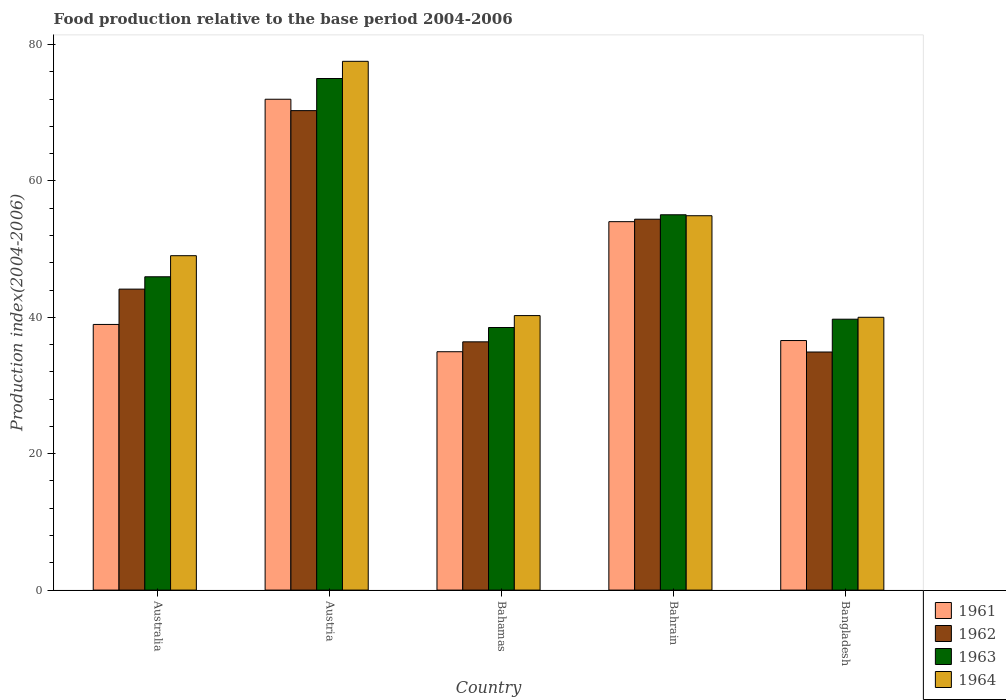How many groups of bars are there?
Provide a succinct answer. 5. Are the number of bars per tick equal to the number of legend labels?
Give a very brief answer. Yes. How many bars are there on the 3rd tick from the left?
Your answer should be very brief. 4. How many bars are there on the 4th tick from the right?
Ensure brevity in your answer.  4. In how many cases, is the number of bars for a given country not equal to the number of legend labels?
Your answer should be very brief. 0. What is the food production index in 1962 in Austria?
Provide a short and direct response. 70.3. Across all countries, what is the maximum food production index in 1961?
Your answer should be compact. 71.97. In which country was the food production index in 1962 maximum?
Make the answer very short. Austria. In which country was the food production index in 1961 minimum?
Your answer should be compact. Bahamas. What is the total food production index in 1964 in the graph?
Ensure brevity in your answer.  261.7. What is the difference between the food production index in 1962 in Bahrain and that in Bangladesh?
Give a very brief answer. 19.47. What is the difference between the food production index in 1964 in Bahrain and the food production index in 1963 in Bangladesh?
Your answer should be very brief. 15.17. What is the average food production index in 1964 per country?
Keep it short and to the point. 52.34. What is the difference between the food production index of/in 1964 and food production index of/in 1963 in Australia?
Make the answer very short. 3.09. What is the ratio of the food production index in 1964 in Australia to that in Austria?
Provide a short and direct response. 0.63. Is the food production index in 1961 in Bahrain less than that in Bangladesh?
Provide a short and direct response. No. Is the difference between the food production index in 1964 in Australia and Bangladesh greater than the difference between the food production index in 1963 in Australia and Bangladesh?
Provide a succinct answer. Yes. What is the difference between the highest and the second highest food production index in 1963?
Keep it short and to the point. 29.07. What is the difference between the highest and the lowest food production index in 1961?
Make the answer very short. 37.02. In how many countries, is the food production index in 1961 greater than the average food production index in 1961 taken over all countries?
Your answer should be compact. 2. Is the sum of the food production index in 1963 in Austria and Bangladesh greater than the maximum food production index in 1964 across all countries?
Offer a terse response. Yes. What does the 3rd bar from the left in Bahamas represents?
Ensure brevity in your answer.  1963. What does the 2nd bar from the right in Bahrain represents?
Provide a succinct answer. 1963. Does the graph contain grids?
Your response must be concise. No. How many legend labels are there?
Keep it short and to the point. 4. How are the legend labels stacked?
Provide a short and direct response. Vertical. What is the title of the graph?
Give a very brief answer. Food production relative to the base period 2004-2006. Does "2004" appear as one of the legend labels in the graph?
Your response must be concise. No. What is the label or title of the Y-axis?
Your response must be concise. Production index(2004-2006). What is the Production index(2004-2006) of 1961 in Australia?
Offer a very short reply. 38.95. What is the Production index(2004-2006) in 1962 in Australia?
Keep it short and to the point. 44.13. What is the Production index(2004-2006) of 1963 in Australia?
Provide a short and direct response. 45.94. What is the Production index(2004-2006) in 1964 in Australia?
Provide a succinct answer. 49.03. What is the Production index(2004-2006) in 1961 in Austria?
Your answer should be compact. 71.97. What is the Production index(2004-2006) in 1962 in Austria?
Your response must be concise. 70.3. What is the Production index(2004-2006) in 1963 in Austria?
Your answer should be very brief. 75.01. What is the Production index(2004-2006) of 1964 in Austria?
Give a very brief answer. 77.53. What is the Production index(2004-2006) in 1961 in Bahamas?
Your response must be concise. 34.95. What is the Production index(2004-2006) in 1962 in Bahamas?
Make the answer very short. 36.4. What is the Production index(2004-2006) in 1963 in Bahamas?
Ensure brevity in your answer.  38.5. What is the Production index(2004-2006) of 1964 in Bahamas?
Keep it short and to the point. 40.25. What is the Production index(2004-2006) of 1961 in Bahrain?
Provide a short and direct response. 54.02. What is the Production index(2004-2006) of 1962 in Bahrain?
Offer a terse response. 54.38. What is the Production index(2004-2006) in 1963 in Bahrain?
Your answer should be compact. 55.03. What is the Production index(2004-2006) in 1964 in Bahrain?
Make the answer very short. 54.89. What is the Production index(2004-2006) in 1961 in Bangladesh?
Provide a succinct answer. 36.59. What is the Production index(2004-2006) in 1962 in Bangladesh?
Make the answer very short. 34.91. What is the Production index(2004-2006) of 1963 in Bangladesh?
Ensure brevity in your answer.  39.72. Across all countries, what is the maximum Production index(2004-2006) of 1961?
Provide a short and direct response. 71.97. Across all countries, what is the maximum Production index(2004-2006) of 1962?
Make the answer very short. 70.3. Across all countries, what is the maximum Production index(2004-2006) in 1963?
Provide a succinct answer. 75.01. Across all countries, what is the maximum Production index(2004-2006) in 1964?
Keep it short and to the point. 77.53. Across all countries, what is the minimum Production index(2004-2006) of 1961?
Your response must be concise. 34.95. Across all countries, what is the minimum Production index(2004-2006) in 1962?
Provide a succinct answer. 34.91. Across all countries, what is the minimum Production index(2004-2006) of 1963?
Your answer should be very brief. 38.5. What is the total Production index(2004-2006) of 1961 in the graph?
Ensure brevity in your answer.  236.48. What is the total Production index(2004-2006) in 1962 in the graph?
Your answer should be very brief. 240.12. What is the total Production index(2004-2006) in 1963 in the graph?
Ensure brevity in your answer.  254.2. What is the total Production index(2004-2006) of 1964 in the graph?
Offer a terse response. 261.7. What is the difference between the Production index(2004-2006) of 1961 in Australia and that in Austria?
Provide a succinct answer. -33.02. What is the difference between the Production index(2004-2006) of 1962 in Australia and that in Austria?
Keep it short and to the point. -26.17. What is the difference between the Production index(2004-2006) of 1963 in Australia and that in Austria?
Your response must be concise. -29.07. What is the difference between the Production index(2004-2006) of 1964 in Australia and that in Austria?
Keep it short and to the point. -28.5. What is the difference between the Production index(2004-2006) in 1961 in Australia and that in Bahamas?
Your response must be concise. 4. What is the difference between the Production index(2004-2006) of 1962 in Australia and that in Bahamas?
Offer a very short reply. 7.73. What is the difference between the Production index(2004-2006) of 1963 in Australia and that in Bahamas?
Your answer should be very brief. 7.44. What is the difference between the Production index(2004-2006) in 1964 in Australia and that in Bahamas?
Offer a terse response. 8.78. What is the difference between the Production index(2004-2006) of 1961 in Australia and that in Bahrain?
Your response must be concise. -15.07. What is the difference between the Production index(2004-2006) in 1962 in Australia and that in Bahrain?
Keep it short and to the point. -10.25. What is the difference between the Production index(2004-2006) in 1963 in Australia and that in Bahrain?
Offer a terse response. -9.09. What is the difference between the Production index(2004-2006) in 1964 in Australia and that in Bahrain?
Offer a terse response. -5.86. What is the difference between the Production index(2004-2006) of 1961 in Australia and that in Bangladesh?
Make the answer very short. 2.36. What is the difference between the Production index(2004-2006) in 1962 in Australia and that in Bangladesh?
Offer a terse response. 9.22. What is the difference between the Production index(2004-2006) in 1963 in Australia and that in Bangladesh?
Keep it short and to the point. 6.22. What is the difference between the Production index(2004-2006) of 1964 in Australia and that in Bangladesh?
Keep it short and to the point. 9.03. What is the difference between the Production index(2004-2006) in 1961 in Austria and that in Bahamas?
Your answer should be compact. 37.02. What is the difference between the Production index(2004-2006) of 1962 in Austria and that in Bahamas?
Give a very brief answer. 33.9. What is the difference between the Production index(2004-2006) of 1963 in Austria and that in Bahamas?
Offer a very short reply. 36.51. What is the difference between the Production index(2004-2006) of 1964 in Austria and that in Bahamas?
Ensure brevity in your answer.  37.28. What is the difference between the Production index(2004-2006) in 1961 in Austria and that in Bahrain?
Provide a short and direct response. 17.95. What is the difference between the Production index(2004-2006) in 1962 in Austria and that in Bahrain?
Your answer should be very brief. 15.92. What is the difference between the Production index(2004-2006) of 1963 in Austria and that in Bahrain?
Make the answer very short. 19.98. What is the difference between the Production index(2004-2006) in 1964 in Austria and that in Bahrain?
Offer a terse response. 22.64. What is the difference between the Production index(2004-2006) in 1961 in Austria and that in Bangladesh?
Make the answer very short. 35.38. What is the difference between the Production index(2004-2006) in 1962 in Austria and that in Bangladesh?
Provide a succinct answer. 35.39. What is the difference between the Production index(2004-2006) in 1963 in Austria and that in Bangladesh?
Your answer should be compact. 35.29. What is the difference between the Production index(2004-2006) of 1964 in Austria and that in Bangladesh?
Offer a very short reply. 37.53. What is the difference between the Production index(2004-2006) of 1961 in Bahamas and that in Bahrain?
Give a very brief answer. -19.07. What is the difference between the Production index(2004-2006) of 1962 in Bahamas and that in Bahrain?
Give a very brief answer. -17.98. What is the difference between the Production index(2004-2006) in 1963 in Bahamas and that in Bahrain?
Your answer should be very brief. -16.53. What is the difference between the Production index(2004-2006) in 1964 in Bahamas and that in Bahrain?
Provide a succinct answer. -14.64. What is the difference between the Production index(2004-2006) in 1961 in Bahamas and that in Bangladesh?
Offer a terse response. -1.64. What is the difference between the Production index(2004-2006) of 1962 in Bahamas and that in Bangladesh?
Give a very brief answer. 1.49. What is the difference between the Production index(2004-2006) of 1963 in Bahamas and that in Bangladesh?
Your answer should be very brief. -1.22. What is the difference between the Production index(2004-2006) in 1964 in Bahamas and that in Bangladesh?
Offer a terse response. 0.25. What is the difference between the Production index(2004-2006) of 1961 in Bahrain and that in Bangladesh?
Provide a succinct answer. 17.43. What is the difference between the Production index(2004-2006) of 1962 in Bahrain and that in Bangladesh?
Make the answer very short. 19.47. What is the difference between the Production index(2004-2006) in 1963 in Bahrain and that in Bangladesh?
Ensure brevity in your answer.  15.31. What is the difference between the Production index(2004-2006) of 1964 in Bahrain and that in Bangladesh?
Provide a short and direct response. 14.89. What is the difference between the Production index(2004-2006) of 1961 in Australia and the Production index(2004-2006) of 1962 in Austria?
Give a very brief answer. -31.35. What is the difference between the Production index(2004-2006) in 1961 in Australia and the Production index(2004-2006) in 1963 in Austria?
Provide a succinct answer. -36.06. What is the difference between the Production index(2004-2006) of 1961 in Australia and the Production index(2004-2006) of 1964 in Austria?
Your answer should be very brief. -38.58. What is the difference between the Production index(2004-2006) in 1962 in Australia and the Production index(2004-2006) in 1963 in Austria?
Offer a terse response. -30.88. What is the difference between the Production index(2004-2006) in 1962 in Australia and the Production index(2004-2006) in 1964 in Austria?
Offer a very short reply. -33.4. What is the difference between the Production index(2004-2006) in 1963 in Australia and the Production index(2004-2006) in 1964 in Austria?
Your response must be concise. -31.59. What is the difference between the Production index(2004-2006) of 1961 in Australia and the Production index(2004-2006) of 1962 in Bahamas?
Make the answer very short. 2.55. What is the difference between the Production index(2004-2006) in 1961 in Australia and the Production index(2004-2006) in 1963 in Bahamas?
Your answer should be compact. 0.45. What is the difference between the Production index(2004-2006) of 1961 in Australia and the Production index(2004-2006) of 1964 in Bahamas?
Provide a short and direct response. -1.3. What is the difference between the Production index(2004-2006) of 1962 in Australia and the Production index(2004-2006) of 1963 in Bahamas?
Your response must be concise. 5.63. What is the difference between the Production index(2004-2006) in 1962 in Australia and the Production index(2004-2006) in 1964 in Bahamas?
Provide a succinct answer. 3.88. What is the difference between the Production index(2004-2006) in 1963 in Australia and the Production index(2004-2006) in 1964 in Bahamas?
Ensure brevity in your answer.  5.69. What is the difference between the Production index(2004-2006) of 1961 in Australia and the Production index(2004-2006) of 1962 in Bahrain?
Offer a very short reply. -15.43. What is the difference between the Production index(2004-2006) of 1961 in Australia and the Production index(2004-2006) of 1963 in Bahrain?
Your answer should be very brief. -16.08. What is the difference between the Production index(2004-2006) of 1961 in Australia and the Production index(2004-2006) of 1964 in Bahrain?
Ensure brevity in your answer.  -15.94. What is the difference between the Production index(2004-2006) in 1962 in Australia and the Production index(2004-2006) in 1963 in Bahrain?
Ensure brevity in your answer.  -10.9. What is the difference between the Production index(2004-2006) in 1962 in Australia and the Production index(2004-2006) in 1964 in Bahrain?
Your answer should be compact. -10.76. What is the difference between the Production index(2004-2006) in 1963 in Australia and the Production index(2004-2006) in 1964 in Bahrain?
Ensure brevity in your answer.  -8.95. What is the difference between the Production index(2004-2006) in 1961 in Australia and the Production index(2004-2006) in 1962 in Bangladesh?
Provide a short and direct response. 4.04. What is the difference between the Production index(2004-2006) of 1961 in Australia and the Production index(2004-2006) of 1963 in Bangladesh?
Offer a very short reply. -0.77. What is the difference between the Production index(2004-2006) of 1961 in Australia and the Production index(2004-2006) of 1964 in Bangladesh?
Offer a very short reply. -1.05. What is the difference between the Production index(2004-2006) of 1962 in Australia and the Production index(2004-2006) of 1963 in Bangladesh?
Keep it short and to the point. 4.41. What is the difference between the Production index(2004-2006) of 1962 in Australia and the Production index(2004-2006) of 1964 in Bangladesh?
Give a very brief answer. 4.13. What is the difference between the Production index(2004-2006) in 1963 in Australia and the Production index(2004-2006) in 1964 in Bangladesh?
Offer a very short reply. 5.94. What is the difference between the Production index(2004-2006) in 1961 in Austria and the Production index(2004-2006) in 1962 in Bahamas?
Keep it short and to the point. 35.57. What is the difference between the Production index(2004-2006) of 1961 in Austria and the Production index(2004-2006) of 1963 in Bahamas?
Your answer should be compact. 33.47. What is the difference between the Production index(2004-2006) of 1961 in Austria and the Production index(2004-2006) of 1964 in Bahamas?
Offer a very short reply. 31.72. What is the difference between the Production index(2004-2006) in 1962 in Austria and the Production index(2004-2006) in 1963 in Bahamas?
Make the answer very short. 31.8. What is the difference between the Production index(2004-2006) of 1962 in Austria and the Production index(2004-2006) of 1964 in Bahamas?
Your response must be concise. 30.05. What is the difference between the Production index(2004-2006) in 1963 in Austria and the Production index(2004-2006) in 1964 in Bahamas?
Your answer should be compact. 34.76. What is the difference between the Production index(2004-2006) in 1961 in Austria and the Production index(2004-2006) in 1962 in Bahrain?
Your response must be concise. 17.59. What is the difference between the Production index(2004-2006) of 1961 in Austria and the Production index(2004-2006) of 1963 in Bahrain?
Keep it short and to the point. 16.94. What is the difference between the Production index(2004-2006) in 1961 in Austria and the Production index(2004-2006) in 1964 in Bahrain?
Keep it short and to the point. 17.08. What is the difference between the Production index(2004-2006) in 1962 in Austria and the Production index(2004-2006) in 1963 in Bahrain?
Keep it short and to the point. 15.27. What is the difference between the Production index(2004-2006) in 1962 in Austria and the Production index(2004-2006) in 1964 in Bahrain?
Offer a terse response. 15.41. What is the difference between the Production index(2004-2006) of 1963 in Austria and the Production index(2004-2006) of 1964 in Bahrain?
Offer a very short reply. 20.12. What is the difference between the Production index(2004-2006) in 1961 in Austria and the Production index(2004-2006) in 1962 in Bangladesh?
Ensure brevity in your answer.  37.06. What is the difference between the Production index(2004-2006) of 1961 in Austria and the Production index(2004-2006) of 1963 in Bangladesh?
Provide a short and direct response. 32.25. What is the difference between the Production index(2004-2006) in 1961 in Austria and the Production index(2004-2006) in 1964 in Bangladesh?
Keep it short and to the point. 31.97. What is the difference between the Production index(2004-2006) of 1962 in Austria and the Production index(2004-2006) of 1963 in Bangladesh?
Provide a succinct answer. 30.58. What is the difference between the Production index(2004-2006) of 1962 in Austria and the Production index(2004-2006) of 1964 in Bangladesh?
Give a very brief answer. 30.3. What is the difference between the Production index(2004-2006) of 1963 in Austria and the Production index(2004-2006) of 1964 in Bangladesh?
Make the answer very short. 35.01. What is the difference between the Production index(2004-2006) in 1961 in Bahamas and the Production index(2004-2006) in 1962 in Bahrain?
Provide a short and direct response. -19.43. What is the difference between the Production index(2004-2006) in 1961 in Bahamas and the Production index(2004-2006) in 1963 in Bahrain?
Ensure brevity in your answer.  -20.08. What is the difference between the Production index(2004-2006) of 1961 in Bahamas and the Production index(2004-2006) of 1964 in Bahrain?
Offer a very short reply. -19.94. What is the difference between the Production index(2004-2006) of 1962 in Bahamas and the Production index(2004-2006) of 1963 in Bahrain?
Offer a terse response. -18.63. What is the difference between the Production index(2004-2006) of 1962 in Bahamas and the Production index(2004-2006) of 1964 in Bahrain?
Your response must be concise. -18.49. What is the difference between the Production index(2004-2006) of 1963 in Bahamas and the Production index(2004-2006) of 1964 in Bahrain?
Offer a very short reply. -16.39. What is the difference between the Production index(2004-2006) of 1961 in Bahamas and the Production index(2004-2006) of 1963 in Bangladesh?
Provide a succinct answer. -4.77. What is the difference between the Production index(2004-2006) in 1961 in Bahamas and the Production index(2004-2006) in 1964 in Bangladesh?
Offer a very short reply. -5.05. What is the difference between the Production index(2004-2006) of 1962 in Bahamas and the Production index(2004-2006) of 1963 in Bangladesh?
Ensure brevity in your answer.  -3.32. What is the difference between the Production index(2004-2006) of 1961 in Bahrain and the Production index(2004-2006) of 1962 in Bangladesh?
Provide a succinct answer. 19.11. What is the difference between the Production index(2004-2006) in 1961 in Bahrain and the Production index(2004-2006) in 1964 in Bangladesh?
Your answer should be very brief. 14.02. What is the difference between the Production index(2004-2006) in 1962 in Bahrain and the Production index(2004-2006) in 1963 in Bangladesh?
Your response must be concise. 14.66. What is the difference between the Production index(2004-2006) in 1962 in Bahrain and the Production index(2004-2006) in 1964 in Bangladesh?
Give a very brief answer. 14.38. What is the difference between the Production index(2004-2006) of 1963 in Bahrain and the Production index(2004-2006) of 1964 in Bangladesh?
Make the answer very short. 15.03. What is the average Production index(2004-2006) of 1961 per country?
Your answer should be compact. 47.3. What is the average Production index(2004-2006) of 1962 per country?
Provide a succinct answer. 48.02. What is the average Production index(2004-2006) of 1963 per country?
Your response must be concise. 50.84. What is the average Production index(2004-2006) in 1964 per country?
Offer a terse response. 52.34. What is the difference between the Production index(2004-2006) of 1961 and Production index(2004-2006) of 1962 in Australia?
Offer a very short reply. -5.18. What is the difference between the Production index(2004-2006) in 1961 and Production index(2004-2006) in 1963 in Australia?
Keep it short and to the point. -6.99. What is the difference between the Production index(2004-2006) of 1961 and Production index(2004-2006) of 1964 in Australia?
Make the answer very short. -10.08. What is the difference between the Production index(2004-2006) in 1962 and Production index(2004-2006) in 1963 in Australia?
Your answer should be compact. -1.81. What is the difference between the Production index(2004-2006) of 1963 and Production index(2004-2006) of 1964 in Australia?
Make the answer very short. -3.09. What is the difference between the Production index(2004-2006) in 1961 and Production index(2004-2006) in 1962 in Austria?
Make the answer very short. 1.67. What is the difference between the Production index(2004-2006) of 1961 and Production index(2004-2006) of 1963 in Austria?
Give a very brief answer. -3.04. What is the difference between the Production index(2004-2006) of 1961 and Production index(2004-2006) of 1964 in Austria?
Provide a short and direct response. -5.56. What is the difference between the Production index(2004-2006) of 1962 and Production index(2004-2006) of 1963 in Austria?
Your answer should be compact. -4.71. What is the difference between the Production index(2004-2006) of 1962 and Production index(2004-2006) of 1964 in Austria?
Offer a terse response. -7.23. What is the difference between the Production index(2004-2006) in 1963 and Production index(2004-2006) in 1964 in Austria?
Ensure brevity in your answer.  -2.52. What is the difference between the Production index(2004-2006) of 1961 and Production index(2004-2006) of 1962 in Bahamas?
Make the answer very short. -1.45. What is the difference between the Production index(2004-2006) in 1961 and Production index(2004-2006) in 1963 in Bahamas?
Your answer should be compact. -3.55. What is the difference between the Production index(2004-2006) in 1961 and Production index(2004-2006) in 1964 in Bahamas?
Give a very brief answer. -5.3. What is the difference between the Production index(2004-2006) in 1962 and Production index(2004-2006) in 1964 in Bahamas?
Provide a short and direct response. -3.85. What is the difference between the Production index(2004-2006) in 1963 and Production index(2004-2006) in 1964 in Bahamas?
Ensure brevity in your answer.  -1.75. What is the difference between the Production index(2004-2006) of 1961 and Production index(2004-2006) of 1962 in Bahrain?
Offer a very short reply. -0.36. What is the difference between the Production index(2004-2006) of 1961 and Production index(2004-2006) of 1963 in Bahrain?
Your answer should be compact. -1.01. What is the difference between the Production index(2004-2006) of 1961 and Production index(2004-2006) of 1964 in Bahrain?
Offer a very short reply. -0.87. What is the difference between the Production index(2004-2006) of 1962 and Production index(2004-2006) of 1963 in Bahrain?
Offer a terse response. -0.65. What is the difference between the Production index(2004-2006) in 1962 and Production index(2004-2006) in 1964 in Bahrain?
Keep it short and to the point. -0.51. What is the difference between the Production index(2004-2006) of 1963 and Production index(2004-2006) of 1964 in Bahrain?
Ensure brevity in your answer.  0.14. What is the difference between the Production index(2004-2006) in 1961 and Production index(2004-2006) in 1962 in Bangladesh?
Your response must be concise. 1.68. What is the difference between the Production index(2004-2006) in 1961 and Production index(2004-2006) in 1963 in Bangladesh?
Your response must be concise. -3.13. What is the difference between the Production index(2004-2006) in 1961 and Production index(2004-2006) in 1964 in Bangladesh?
Your answer should be very brief. -3.41. What is the difference between the Production index(2004-2006) of 1962 and Production index(2004-2006) of 1963 in Bangladesh?
Give a very brief answer. -4.81. What is the difference between the Production index(2004-2006) of 1962 and Production index(2004-2006) of 1964 in Bangladesh?
Give a very brief answer. -5.09. What is the difference between the Production index(2004-2006) of 1963 and Production index(2004-2006) of 1964 in Bangladesh?
Provide a short and direct response. -0.28. What is the ratio of the Production index(2004-2006) of 1961 in Australia to that in Austria?
Offer a very short reply. 0.54. What is the ratio of the Production index(2004-2006) of 1962 in Australia to that in Austria?
Provide a succinct answer. 0.63. What is the ratio of the Production index(2004-2006) in 1963 in Australia to that in Austria?
Your answer should be compact. 0.61. What is the ratio of the Production index(2004-2006) in 1964 in Australia to that in Austria?
Keep it short and to the point. 0.63. What is the ratio of the Production index(2004-2006) in 1961 in Australia to that in Bahamas?
Provide a succinct answer. 1.11. What is the ratio of the Production index(2004-2006) of 1962 in Australia to that in Bahamas?
Offer a terse response. 1.21. What is the ratio of the Production index(2004-2006) of 1963 in Australia to that in Bahamas?
Offer a very short reply. 1.19. What is the ratio of the Production index(2004-2006) of 1964 in Australia to that in Bahamas?
Offer a very short reply. 1.22. What is the ratio of the Production index(2004-2006) of 1961 in Australia to that in Bahrain?
Offer a very short reply. 0.72. What is the ratio of the Production index(2004-2006) in 1962 in Australia to that in Bahrain?
Your answer should be compact. 0.81. What is the ratio of the Production index(2004-2006) in 1963 in Australia to that in Bahrain?
Your answer should be compact. 0.83. What is the ratio of the Production index(2004-2006) in 1964 in Australia to that in Bahrain?
Offer a very short reply. 0.89. What is the ratio of the Production index(2004-2006) of 1961 in Australia to that in Bangladesh?
Provide a short and direct response. 1.06. What is the ratio of the Production index(2004-2006) in 1962 in Australia to that in Bangladesh?
Offer a terse response. 1.26. What is the ratio of the Production index(2004-2006) in 1963 in Australia to that in Bangladesh?
Provide a succinct answer. 1.16. What is the ratio of the Production index(2004-2006) of 1964 in Australia to that in Bangladesh?
Offer a very short reply. 1.23. What is the ratio of the Production index(2004-2006) of 1961 in Austria to that in Bahamas?
Your answer should be compact. 2.06. What is the ratio of the Production index(2004-2006) in 1962 in Austria to that in Bahamas?
Offer a very short reply. 1.93. What is the ratio of the Production index(2004-2006) of 1963 in Austria to that in Bahamas?
Ensure brevity in your answer.  1.95. What is the ratio of the Production index(2004-2006) of 1964 in Austria to that in Bahamas?
Your answer should be very brief. 1.93. What is the ratio of the Production index(2004-2006) in 1961 in Austria to that in Bahrain?
Provide a succinct answer. 1.33. What is the ratio of the Production index(2004-2006) in 1962 in Austria to that in Bahrain?
Provide a succinct answer. 1.29. What is the ratio of the Production index(2004-2006) of 1963 in Austria to that in Bahrain?
Offer a terse response. 1.36. What is the ratio of the Production index(2004-2006) in 1964 in Austria to that in Bahrain?
Your response must be concise. 1.41. What is the ratio of the Production index(2004-2006) of 1961 in Austria to that in Bangladesh?
Make the answer very short. 1.97. What is the ratio of the Production index(2004-2006) in 1962 in Austria to that in Bangladesh?
Your answer should be very brief. 2.01. What is the ratio of the Production index(2004-2006) of 1963 in Austria to that in Bangladesh?
Your answer should be very brief. 1.89. What is the ratio of the Production index(2004-2006) in 1964 in Austria to that in Bangladesh?
Provide a succinct answer. 1.94. What is the ratio of the Production index(2004-2006) in 1961 in Bahamas to that in Bahrain?
Make the answer very short. 0.65. What is the ratio of the Production index(2004-2006) in 1962 in Bahamas to that in Bahrain?
Your answer should be compact. 0.67. What is the ratio of the Production index(2004-2006) of 1963 in Bahamas to that in Bahrain?
Give a very brief answer. 0.7. What is the ratio of the Production index(2004-2006) of 1964 in Bahamas to that in Bahrain?
Offer a terse response. 0.73. What is the ratio of the Production index(2004-2006) in 1961 in Bahamas to that in Bangladesh?
Your answer should be compact. 0.96. What is the ratio of the Production index(2004-2006) of 1962 in Bahamas to that in Bangladesh?
Ensure brevity in your answer.  1.04. What is the ratio of the Production index(2004-2006) in 1963 in Bahamas to that in Bangladesh?
Your answer should be very brief. 0.97. What is the ratio of the Production index(2004-2006) in 1964 in Bahamas to that in Bangladesh?
Ensure brevity in your answer.  1.01. What is the ratio of the Production index(2004-2006) in 1961 in Bahrain to that in Bangladesh?
Your answer should be very brief. 1.48. What is the ratio of the Production index(2004-2006) of 1962 in Bahrain to that in Bangladesh?
Keep it short and to the point. 1.56. What is the ratio of the Production index(2004-2006) of 1963 in Bahrain to that in Bangladesh?
Your response must be concise. 1.39. What is the ratio of the Production index(2004-2006) in 1964 in Bahrain to that in Bangladesh?
Offer a terse response. 1.37. What is the difference between the highest and the second highest Production index(2004-2006) in 1961?
Ensure brevity in your answer.  17.95. What is the difference between the highest and the second highest Production index(2004-2006) in 1962?
Your response must be concise. 15.92. What is the difference between the highest and the second highest Production index(2004-2006) in 1963?
Make the answer very short. 19.98. What is the difference between the highest and the second highest Production index(2004-2006) of 1964?
Your response must be concise. 22.64. What is the difference between the highest and the lowest Production index(2004-2006) in 1961?
Provide a succinct answer. 37.02. What is the difference between the highest and the lowest Production index(2004-2006) of 1962?
Make the answer very short. 35.39. What is the difference between the highest and the lowest Production index(2004-2006) of 1963?
Provide a succinct answer. 36.51. What is the difference between the highest and the lowest Production index(2004-2006) of 1964?
Provide a succinct answer. 37.53. 